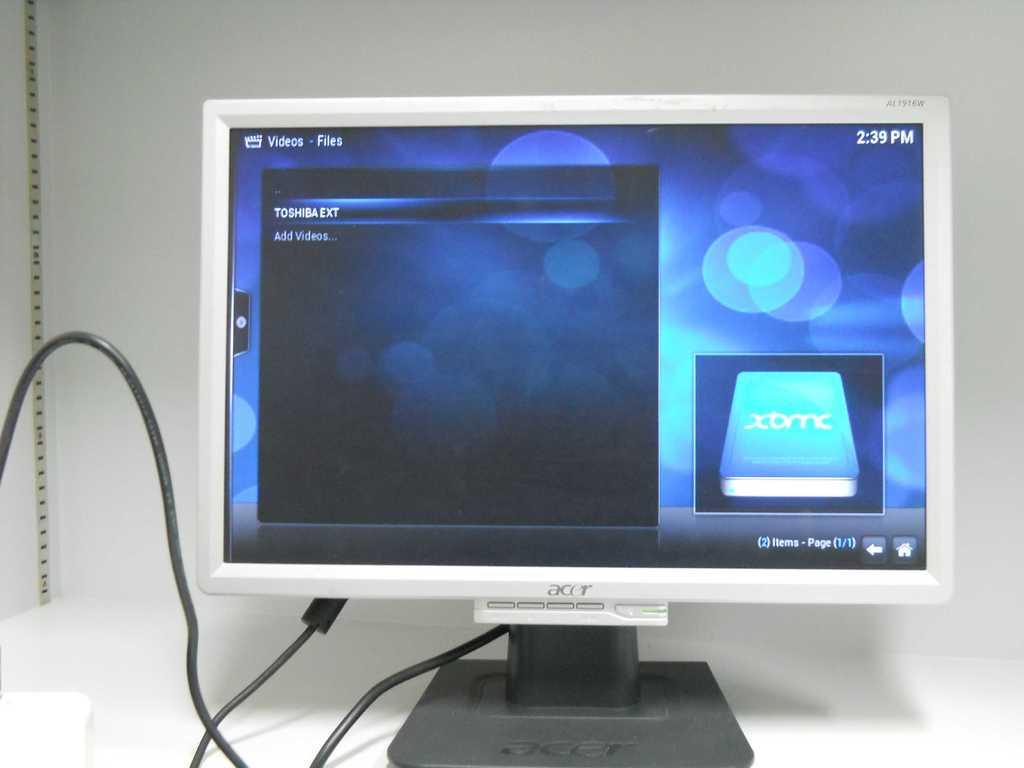What electronic device is visible in the image? There is a computer in the image. Where is the computer located? The computer is placed on a table. What can be seen in the background of the image? There is a wall in the background of the image. What type of support does the computer provide to society in the image? The image does not show the computer providing any support to society; it only depicts the computer on a table. 